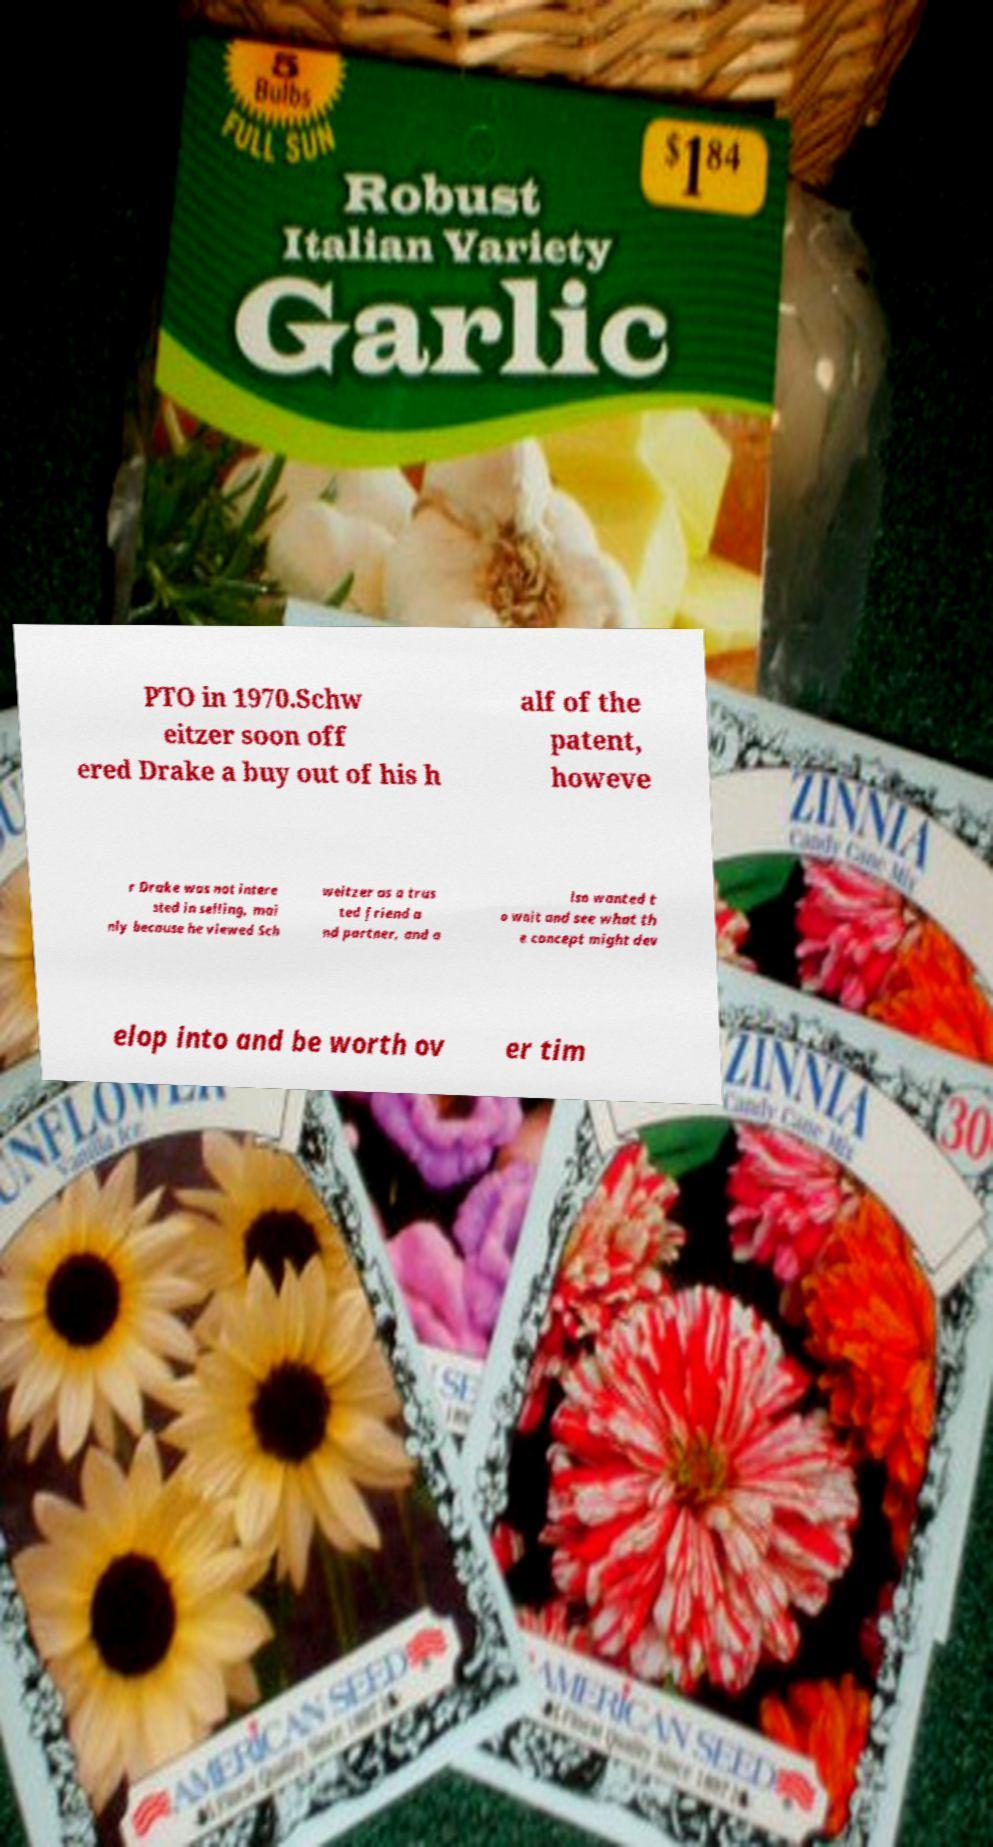I need the written content from this picture converted into text. Can you do that? PTO in 1970.Schw eitzer soon off ered Drake a buy out of his h alf of the patent, howeve r Drake was not intere sted in selling, mai nly because he viewed Sch weitzer as a trus ted friend a nd partner, and a lso wanted t o wait and see what th e concept might dev elop into and be worth ov er tim 